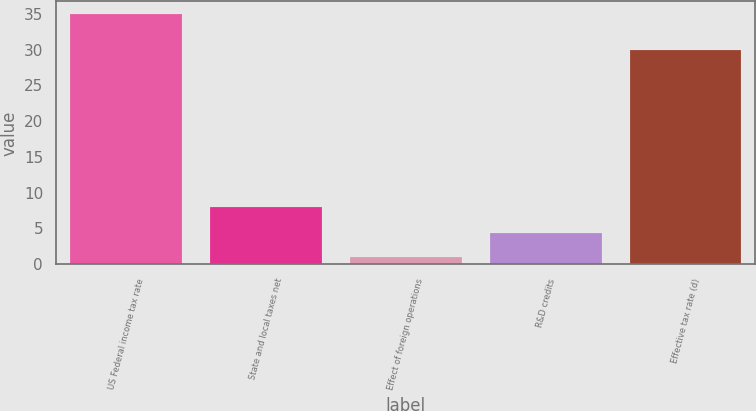Convert chart. <chart><loc_0><loc_0><loc_500><loc_500><bar_chart><fcel>US Federal income tax rate<fcel>State and local taxes net<fcel>Effect of foreign operations<fcel>R&D credits<fcel>Effective tax rate (d)<nl><fcel>35<fcel>8<fcel>1<fcel>4.4<fcel>30<nl></chart> 